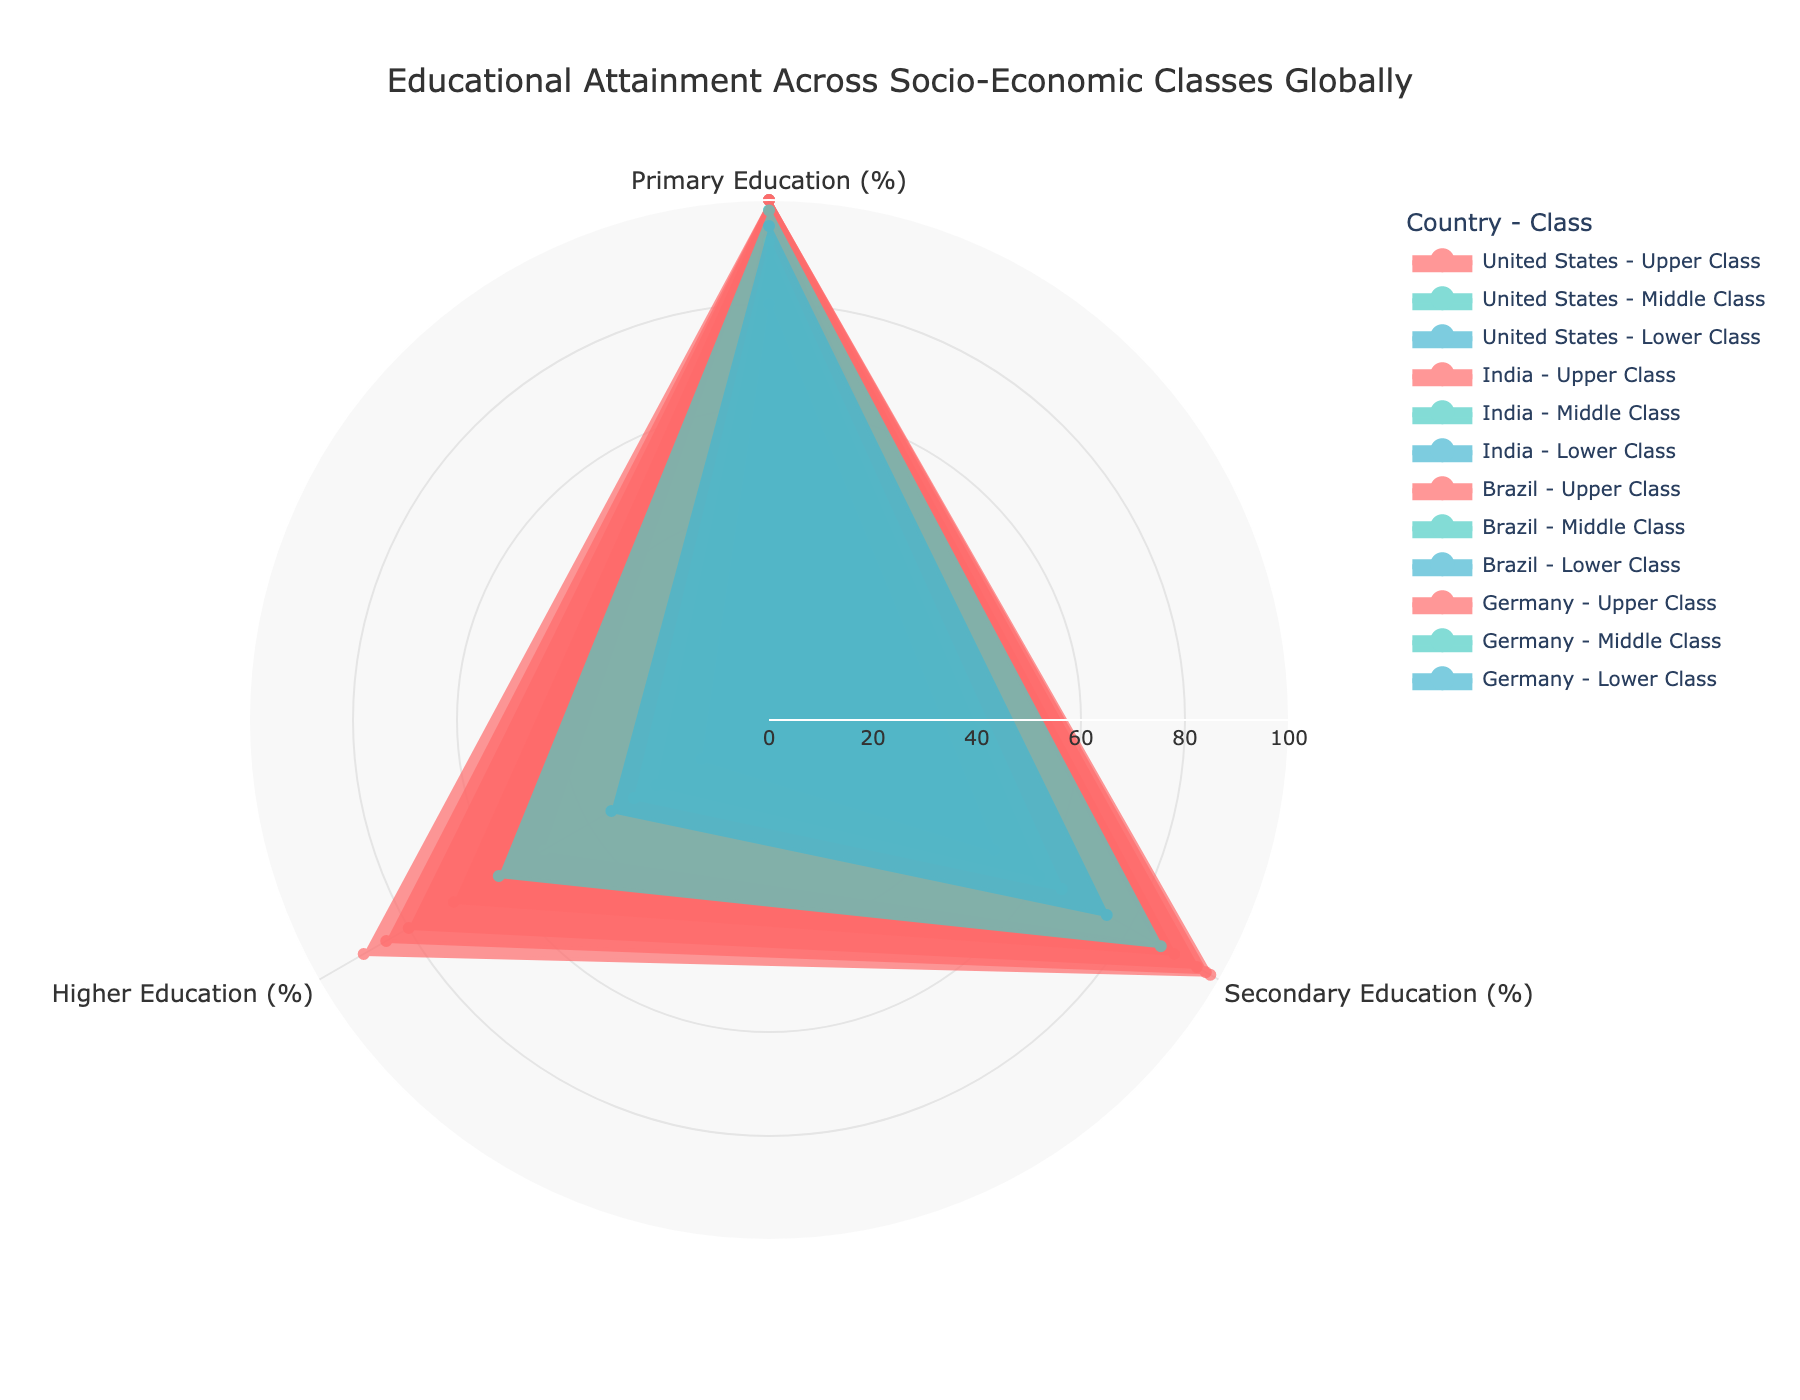What's the title of the figure? The title is located at the top of the figure. It reads "Educational Attainment Across Socio-Economic Classes Globally."
Answer: Educational Attainment Across Socio-Economic Classes Globally Which socio-economic class in India has the highest percentage of primary education attainment? Look at the radial segment labeled "Primary Education (%)" for India and identify the socio-economic class with the highest percentage that reaches the outermost ring.
Answer: Upper Class What is the percentage of higher education attainment in Brazil's lower class? Look at the radial segment labeled "Higher Education (%)" corresponding to Brazil's lower class. The value is displayed on the plot.
Answer: 15% Compare the secondary education attainment between Germany's middle and lower classes. Which is higher? Compare the values on the radial segment labeled "Secondary Education (%)" for Germany's middle class and lower class. The middle class has a higher percentage as it is closer to the outer ring.
Answer: Middle Class What is the average percentage of higher education attainment in the United States across all socio-economic classes? Find the values for higher education attainment for all three classes in the United States and calculate the average: (90 + 50 + 30) / 3 = 56.7
Answer: 56.7 Which country shows the most significant disparity in higher education attainment between upper and lower classes? Compare the gap between the upper and lower class percentages for higher education in each country. The largest difference is in India: 80% - 10% = 70%.
Answer: India How does the primary education attainment in the lower class of Brazil compare to that in the lower class of Germany? Look at the radial segment labeled "Primary Education (%)" for the lower class in both Brazil and Germany, then compare. Both have high values, but Germany's lower class is slightly higher.
Answer: Germany's lower class Which socio-economic class in the United States has the lowest secondary education attainment? Check the values on the radial segment labeled "Secondary Education (%)" for all classes in the United States. The lower class has the smallest percentage.
Answer: Lower Class Considering all socio-economic classes in each country, which country has the lowest overall percentage of higher education attainment? Average the higher education percentages for all socio-economic classes in each country and compare. India's averages: (80 + 25 + 10) / 3 = 38.33, which is the lowest among the four countries.
Answer: India What is the trend in secondary education attainment from the lower class to the upper class in Germany? Analyze the data points for secondary education (%) in Germany from the lower to the middle to the upper class. It shows an upward trend: 75% (lower) -> 87% (middle) -> 97% (upper).
Answer: Upward Trend 